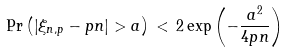Convert formula to latex. <formula><loc_0><loc_0><loc_500><loc_500>\Pr \left ( \left | \xi _ { n , p } - p n \right | > a \right ) \, < \, 2 \exp \left ( - \frac { a ^ { 2 } } { 4 p n } \right )</formula> 